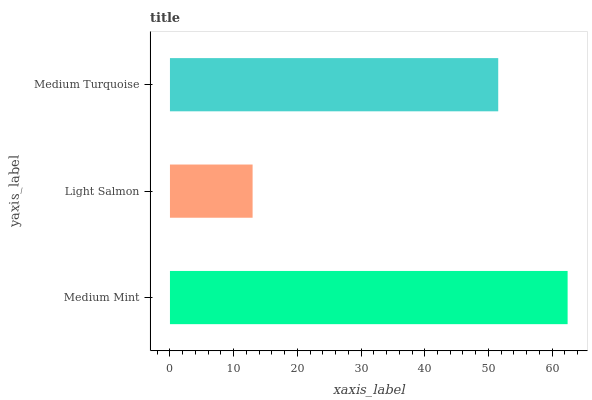Is Light Salmon the minimum?
Answer yes or no. Yes. Is Medium Mint the maximum?
Answer yes or no. Yes. Is Medium Turquoise the minimum?
Answer yes or no. No. Is Medium Turquoise the maximum?
Answer yes or no. No. Is Medium Turquoise greater than Light Salmon?
Answer yes or no. Yes. Is Light Salmon less than Medium Turquoise?
Answer yes or no. Yes. Is Light Salmon greater than Medium Turquoise?
Answer yes or no. No. Is Medium Turquoise less than Light Salmon?
Answer yes or no. No. Is Medium Turquoise the high median?
Answer yes or no. Yes. Is Medium Turquoise the low median?
Answer yes or no. Yes. Is Medium Mint the high median?
Answer yes or no. No. Is Medium Mint the low median?
Answer yes or no. No. 